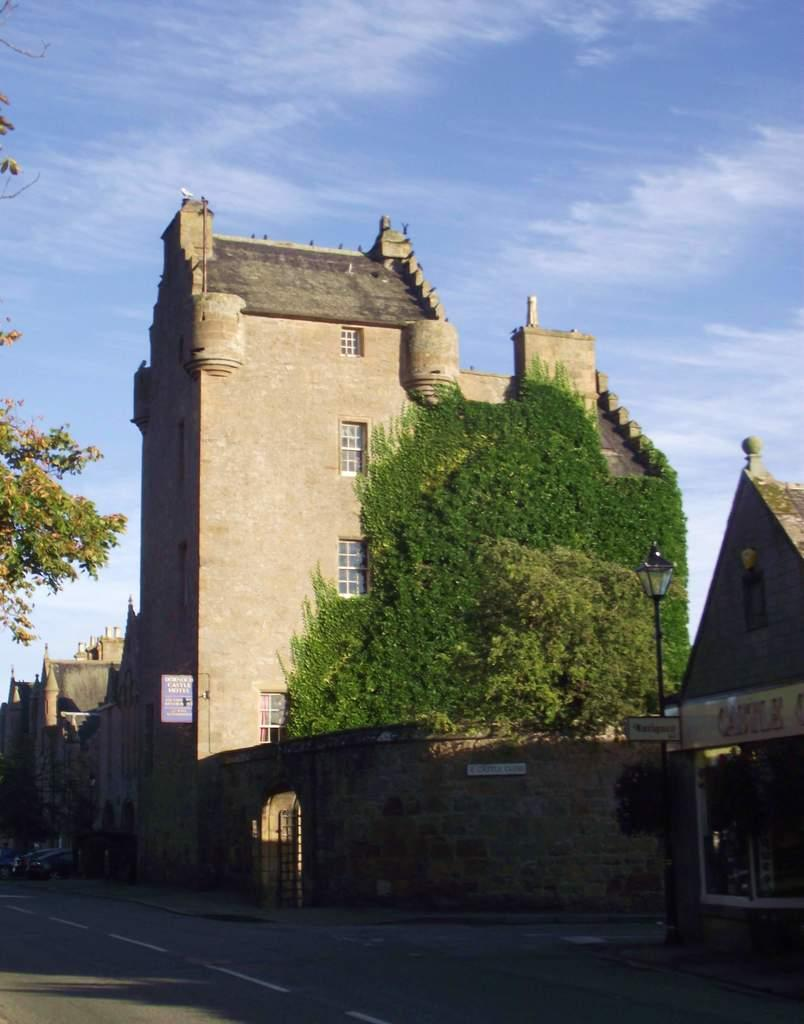What type of structure is visible in the image? There is a house in the image, along with other buildings. What are some features of the buildings in the image? The buildings have walls and windows. What other objects can be seen in the image? There are trees, boards, poles, and vehicles in the image. What is the setting of the image? The image shows a road at the bottom, with buildings and other objects surrounding it. What can be seen in the background of the image? The sky is visible in the background of the image. What type of bone is used as a whistle in the image? There is no bone or whistle present in the image. What is the purpose of the house in the image? The purpose of the house in the image cannot be determined from the image alone, as it does not show any inhabitants or activities taking place inside. 